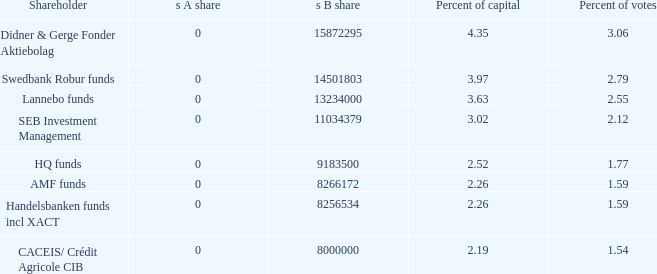What is the s B share for Handelsbanken funds incl XACT? 8256534.0. 